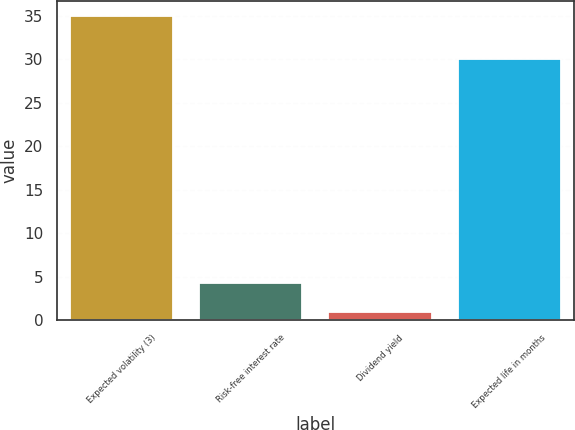<chart> <loc_0><loc_0><loc_500><loc_500><bar_chart><fcel>Expected volatility (3)<fcel>Risk-free interest rate<fcel>Dividend yield<fcel>Expected life in months<nl><fcel>35<fcel>4.29<fcel>0.88<fcel>30<nl></chart> 